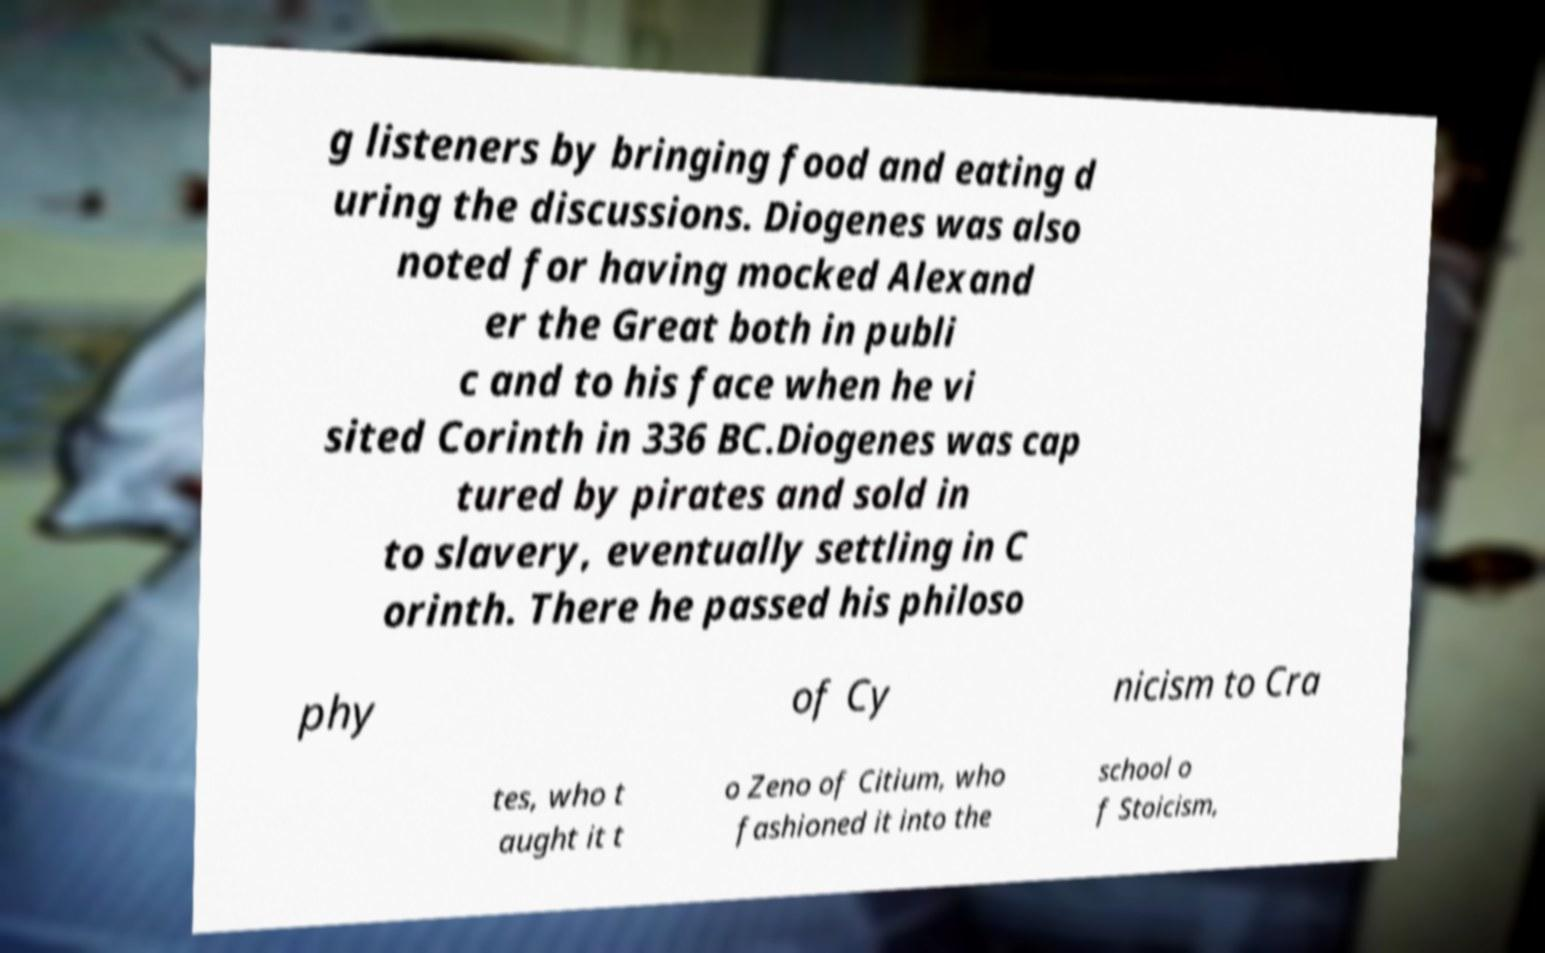Please read and relay the text visible in this image. What does it say? g listeners by bringing food and eating d uring the discussions. Diogenes was also noted for having mocked Alexand er the Great both in publi c and to his face when he vi sited Corinth in 336 BC.Diogenes was cap tured by pirates and sold in to slavery, eventually settling in C orinth. There he passed his philoso phy of Cy nicism to Cra tes, who t aught it t o Zeno of Citium, who fashioned it into the school o f Stoicism, 